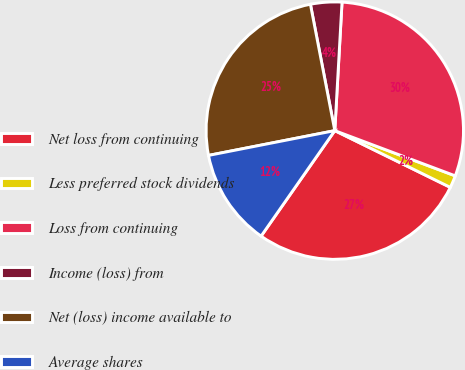Convert chart to OTSL. <chart><loc_0><loc_0><loc_500><loc_500><pie_chart><fcel>Net loss from continuing<fcel>Less preferred stock dividends<fcel>Loss from continuing<fcel>Income (loss) from<fcel>Net (loss) income available to<fcel>Average shares<nl><fcel>27.44%<fcel>1.55%<fcel>29.82%<fcel>3.93%<fcel>25.05%<fcel>12.21%<nl></chart> 